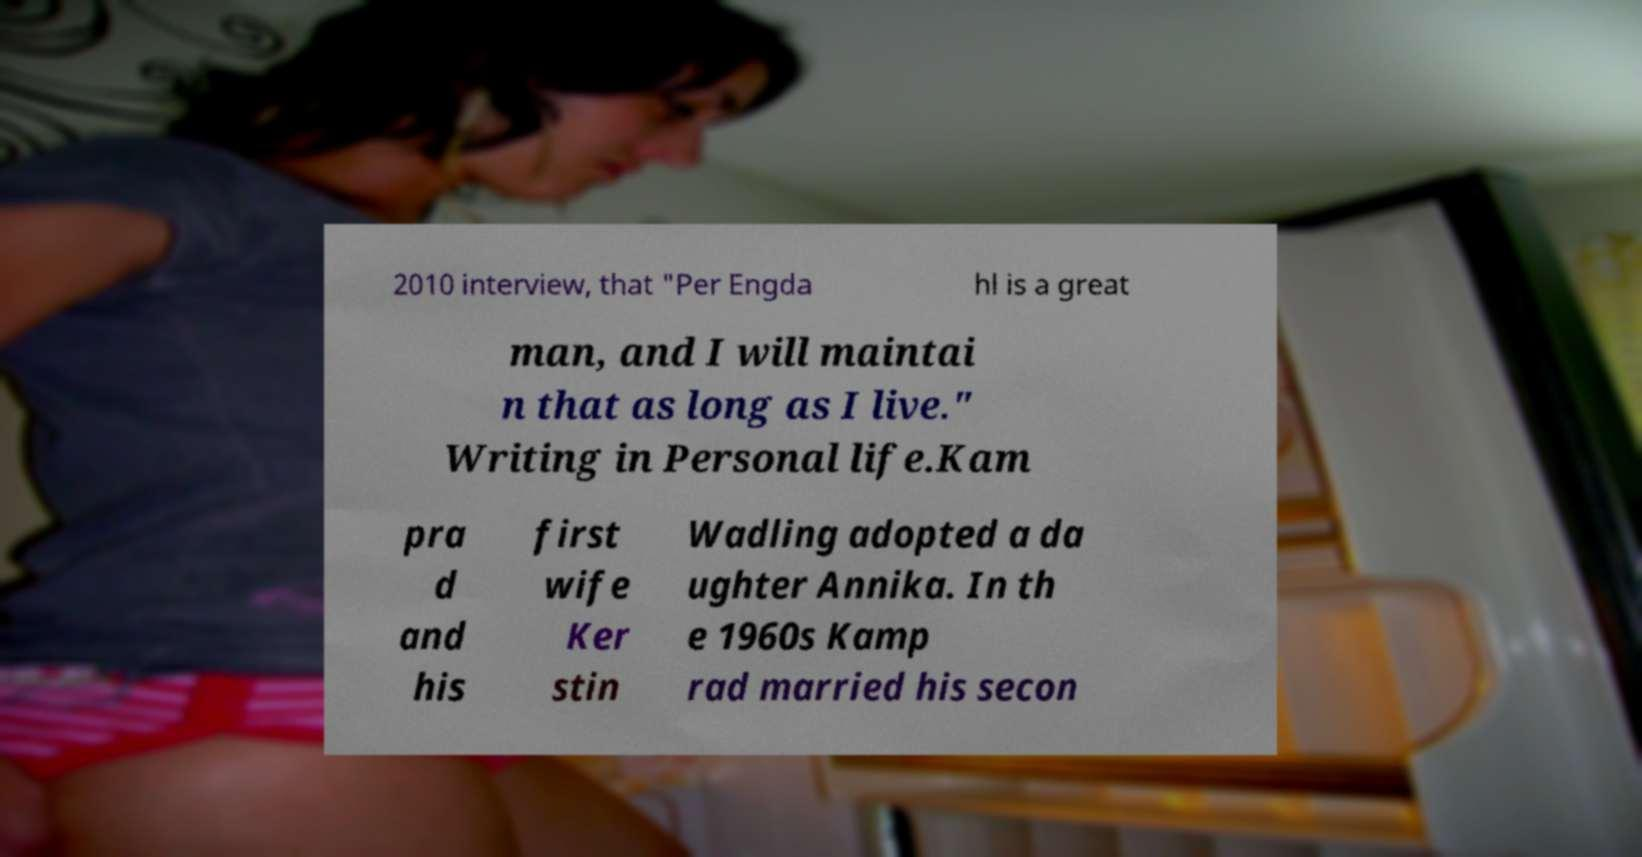There's text embedded in this image that I need extracted. Can you transcribe it verbatim? 2010 interview, that "Per Engda hl is a great man, and I will maintai n that as long as I live." Writing in Personal life.Kam pra d and his first wife Ker stin Wadling adopted a da ughter Annika. In th e 1960s Kamp rad married his secon 